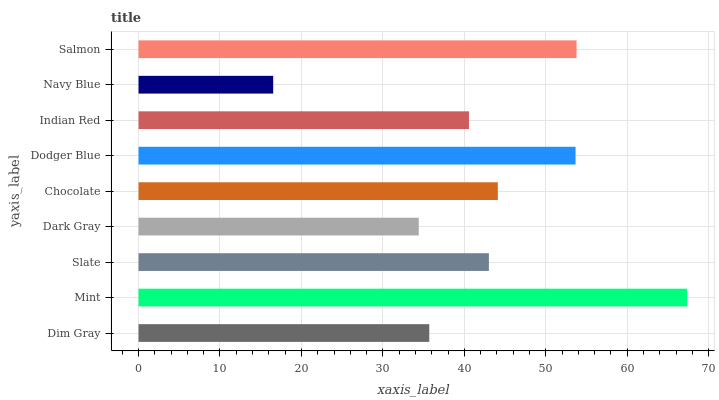Is Navy Blue the minimum?
Answer yes or no. Yes. Is Mint the maximum?
Answer yes or no. Yes. Is Slate the minimum?
Answer yes or no. No. Is Slate the maximum?
Answer yes or no. No. Is Mint greater than Slate?
Answer yes or no. Yes. Is Slate less than Mint?
Answer yes or no. Yes. Is Slate greater than Mint?
Answer yes or no. No. Is Mint less than Slate?
Answer yes or no. No. Is Slate the high median?
Answer yes or no. Yes. Is Slate the low median?
Answer yes or no. Yes. Is Dodger Blue the high median?
Answer yes or no. No. Is Chocolate the low median?
Answer yes or no. No. 